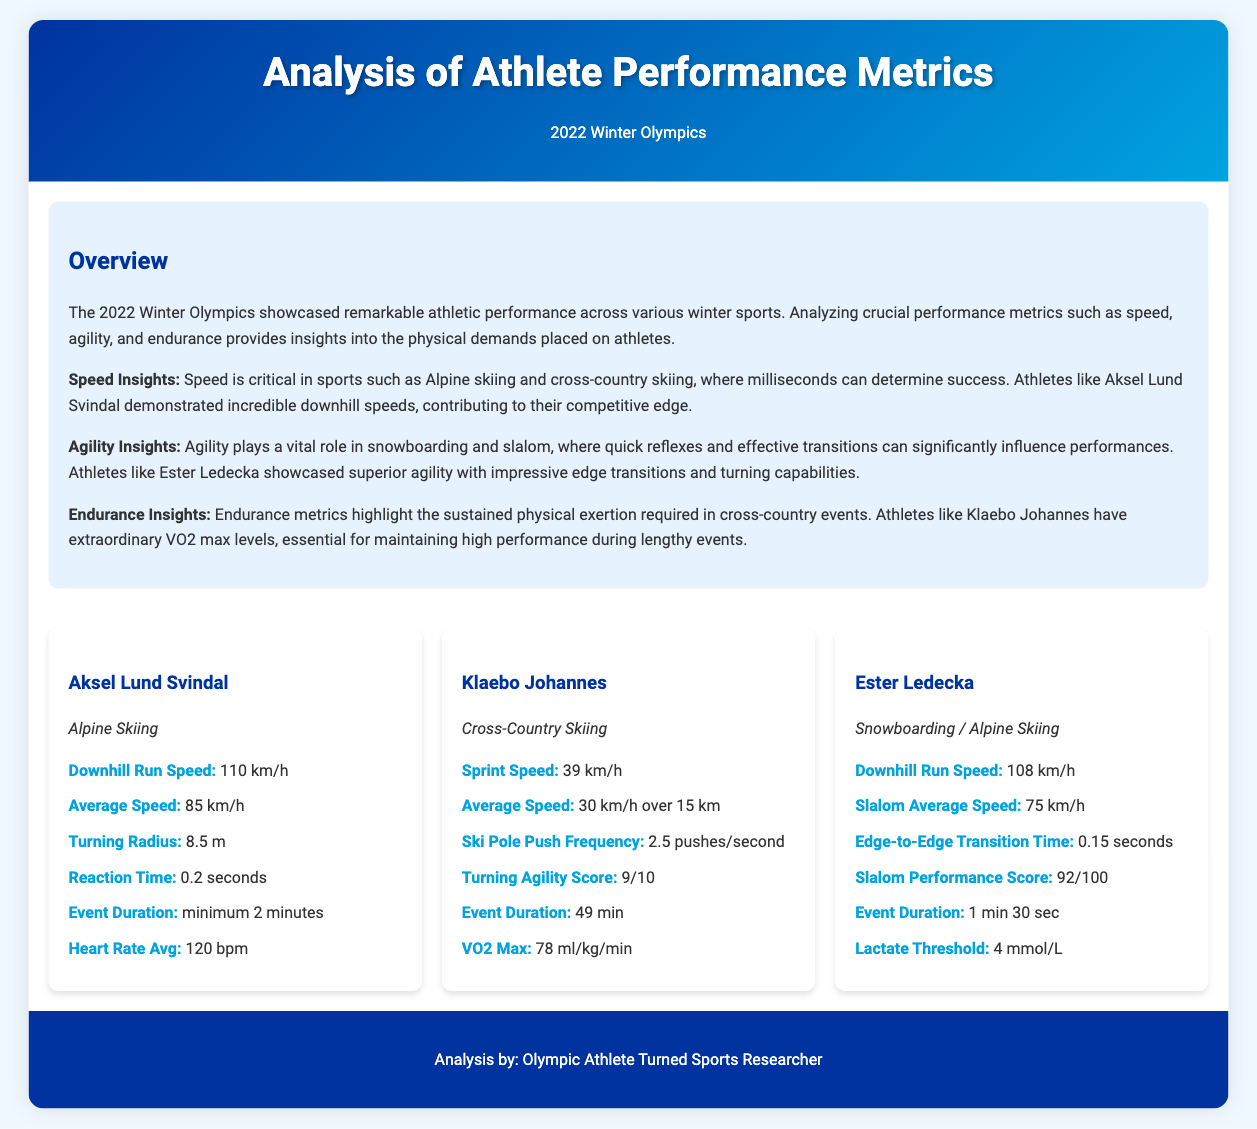What is Aksel Lund Svindal's downhill run speed? The document states that Aksel Lund Svindal has a downhill run speed of 110 km/h.
Answer: 110 km/h What is Klaebo Johannes' VO2 Max? The document indicates that Klaebo Johannes has a VO2 Max of 78 ml/kg/min.
Answer: 78 ml/kg/min What is the slalom performance score of Ester Ledecka? According to the document, Ester Ledecka has a slalom performance score of 92/100.
Answer: 92/100 Which athlete has the highest average speed? The document highlights that Aksel Lund Svindal has an average speed of 85 km/h, which is higher than others.
Answer: Aksel Lund Svindal What endurance metric is highlighted for Klaebo Johannes? The document discusses Klaebo Johannes' extraordinary VO2 max levels, essential for maintaining high performance.
Answer: VO2 max levels How long is the event duration for Klaebo Johannes? The document provides that the event duration for Klaebo Johannes is 49 minutes.
Answer: 49 min What role does agility play in snowboarding? The document states that agility is vital in snowboarding, where quick reflexes influence performances.
Answer: Quick reflexes What is the average heart rate of Aksel Lund Svindal? The document lists Aksel Lund Svindal's average heart rate as 120 bpm.
Answer: 120 bpm What is the reaction time recorded for Aksel Lund Svindal? The document mentions that Aksel Lund Svindal's reaction time is 0.2 seconds.
Answer: 0.2 seconds 